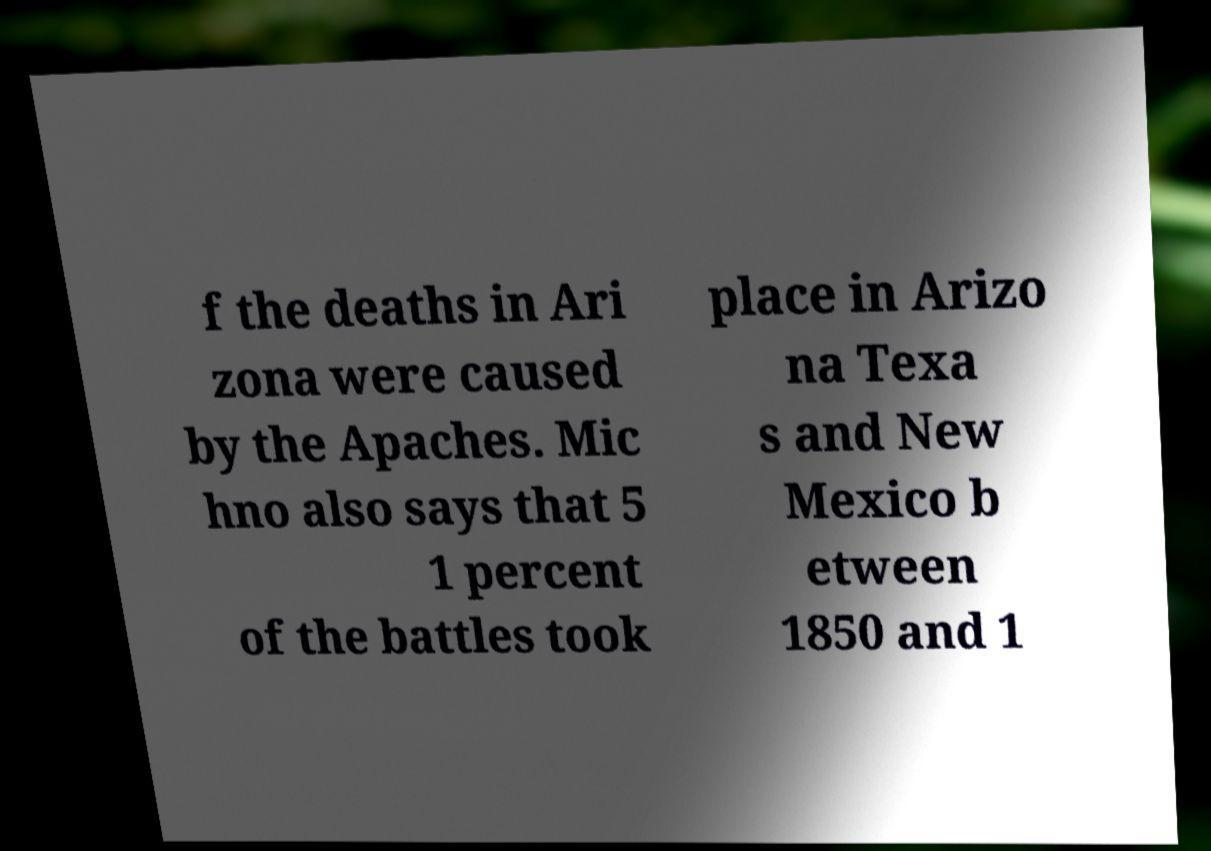For documentation purposes, I need the text within this image transcribed. Could you provide that? f the deaths in Ari zona were caused by the Apaches. Mic hno also says that 5 1 percent of the battles took place in Arizo na Texa s and New Mexico b etween 1850 and 1 